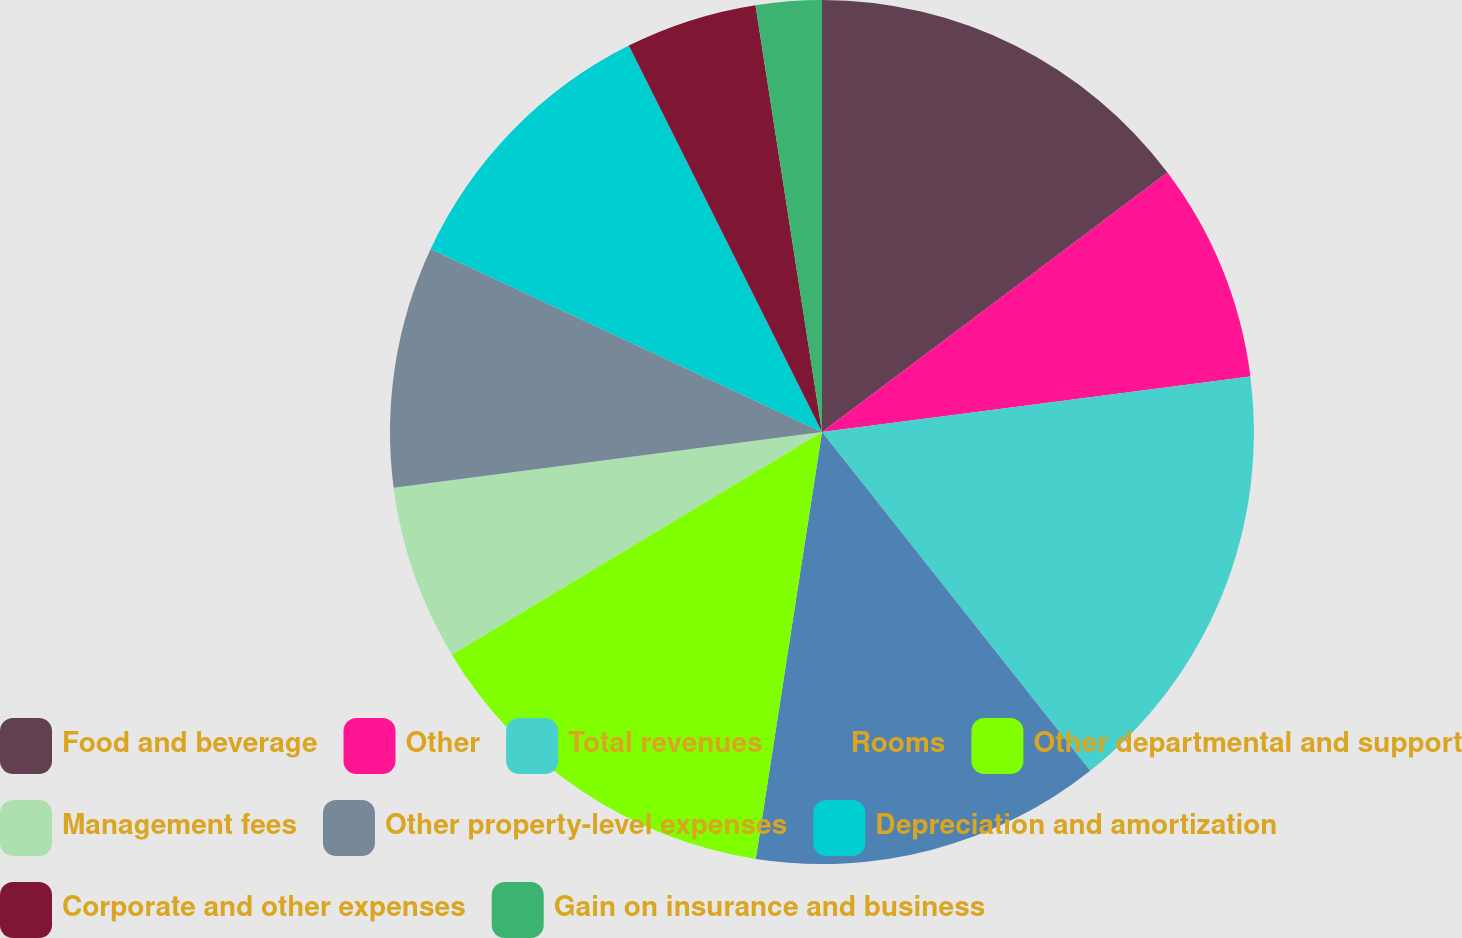Convert chart. <chart><loc_0><loc_0><loc_500><loc_500><pie_chart><fcel>Food and beverage<fcel>Other<fcel>Total revenues<fcel>Rooms<fcel>Other departmental and support<fcel>Management fees<fcel>Other property-level expenses<fcel>Depreciation and amortization<fcel>Corporate and other expenses<fcel>Gain on insurance and business<nl><fcel>14.75%<fcel>8.2%<fcel>16.39%<fcel>13.11%<fcel>13.93%<fcel>6.56%<fcel>9.02%<fcel>10.66%<fcel>4.92%<fcel>2.46%<nl></chart> 